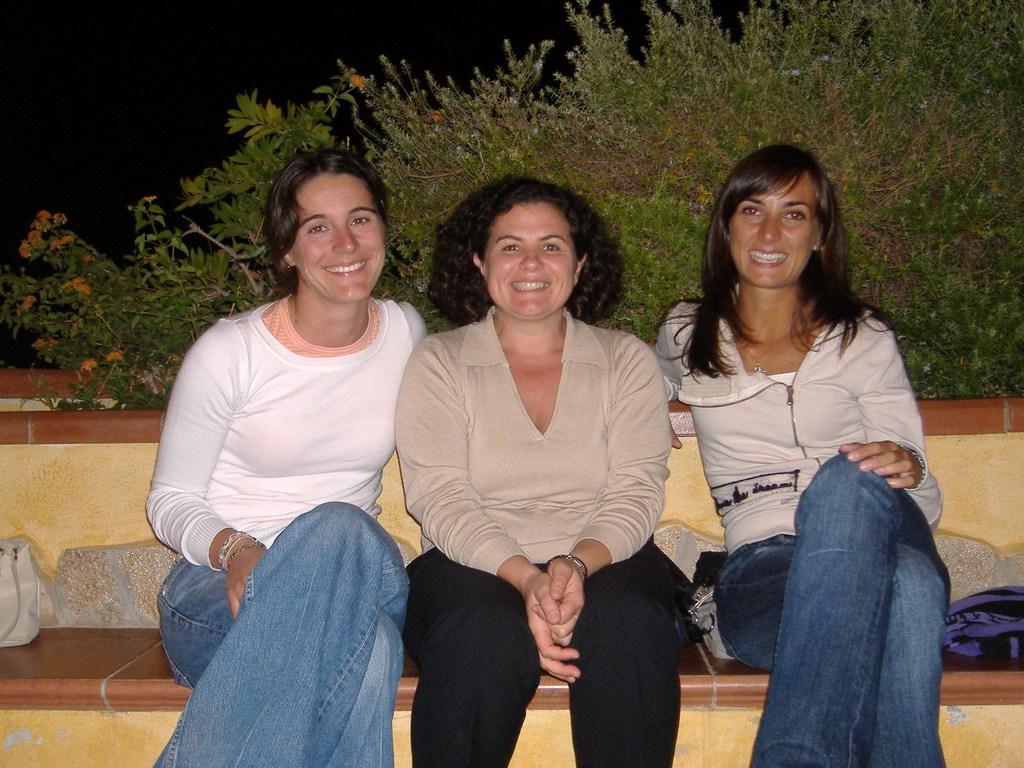Could you give a brief overview of what you see in this image? These people are sitting and smiling. Background there are plants. 